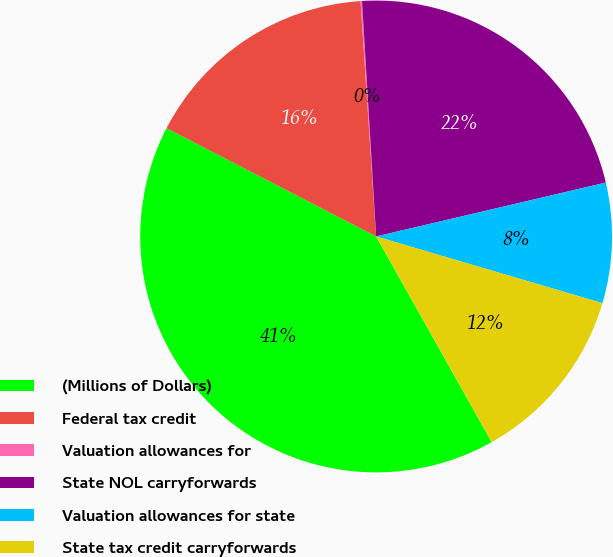Convert chart. <chart><loc_0><loc_0><loc_500><loc_500><pie_chart><fcel>(Millions of Dollars)<fcel>Federal tax credit<fcel>Valuation allowances for<fcel>State NOL carryforwards<fcel>Valuation allowances for state<fcel>State tax credit carryforwards<nl><fcel>40.74%<fcel>16.36%<fcel>0.1%<fcel>22.29%<fcel>8.23%<fcel>12.29%<nl></chart> 